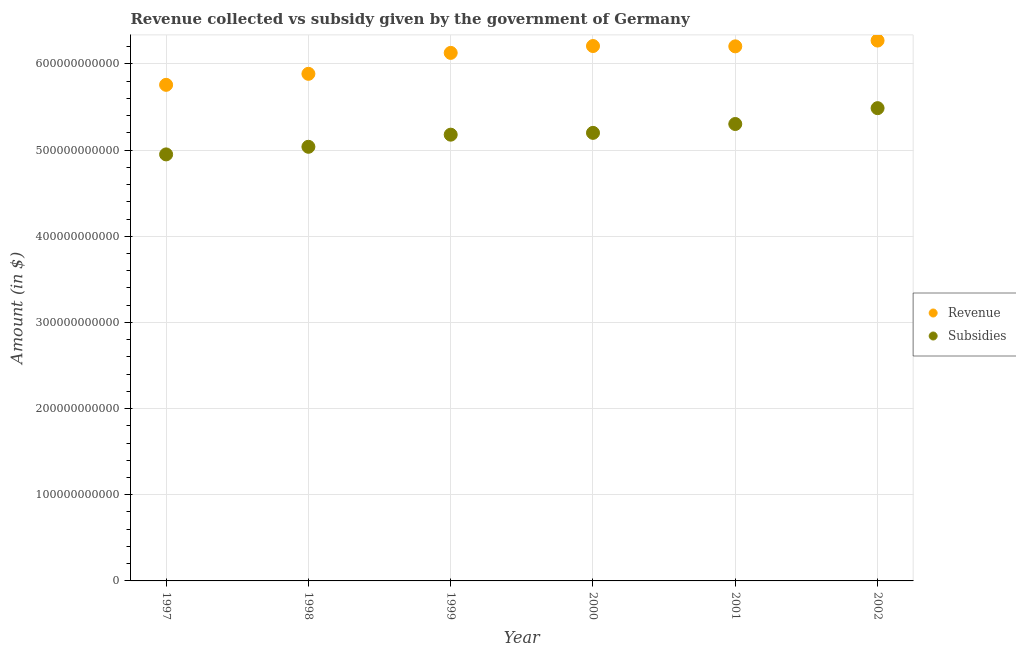Is the number of dotlines equal to the number of legend labels?
Keep it short and to the point. Yes. What is the amount of subsidies given in 1997?
Your answer should be compact. 4.95e+11. Across all years, what is the maximum amount of subsidies given?
Your answer should be compact. 5.49e+11. Across all years, what is the minimum amount of revenue collected?
Your response must be concise. 5.76e+11. In which year was the amount of subsidies given maximum?
Make the answer very short. 2002. What is the total amount of subsidies given in the graph?
Offer a terse response. 3.12e+12. What is the difference between the amount of revenue collected in 1998 and that in 2002?
Your response must be concise. -3.86e+1. What is the difference between the amount of revenue collected in 2001 and the amount of subsidies given in 2000?
Offer a terse response. 1.00e+11. What is the average amount of subsidies given per year?
Keep it short and to the point. 5.19e+11. In the year 2001, what is the difference between the amount of subsidies given and amount of revenue collected?
Ensure brevity in your answer.  -9.01e+1. What is the ratio of the amount of subsidies given in 2000 to that in 2001?
Offer a very short reply. 0.98. Is the difference between the amount of revenue collected in 1997 and 2001 greater than the difference between the amount of subsidies given in 1997 and 2001?
Give a very brief answer. No. What is the difference between the highest and the second highest amount of revenue collected?
Your answer should be very brief. 6.34e+09. What is the difference between the highest and the lowest amount of revenue collected?
Offer a terse response. 5.14e+1. In how many years, is the amount of subsidies given greater than the average amount of subsidies given taken over all years?
Your answer should be very brief. 3. Is the sum of the amount of revenue collected in 2000 and 2001 greater than the maximum amount of subsidies given across all years?
Ensure brevity in your answer.  Yes. Does the amount of subsidies given monotonically increase over the years?
Offer a very short reply. Yes. How many dotlines are there?
Your response must be concise. 2. What is the difference between two consecutive major ticks on the Y-axis?
Your answer should be very brief. 1.00e+11. Does the graph contain grids?
Offer a terse response. Yes. How many legend labels are there?
Keep it short and to the point. 2. What is the title of the graph?
Keep it short and to the point. Revenue collected vs subsidy given by the government of Germany. Does "Forest land" appear as one of the legend labels in the graph?
Provide a succinct answer. No. What is the label or title of the Y-axis?
Your response must be concise. Amount (in $). What is the Amount (in $) in Revenue in 1997?
Offer a very short reply. 5.76e+11. What is the Amount (in $) in Subsidies in 1997?
Give a very brief answer. 4.95e+11. What is the Amount (in $) of Revenue in 1998?
Your response must be concise. 5.89e+11. What is the Amount (in $) in Subsidies in 1998?
Your answer should be compact. 5.04e+11. What is the Amount (in $) of Revenue in 1999?
Provide a succinct answer. 6.13e+11. What is the Amount (in $) of Subsidies in 1999?
Your answer should be compact. 5.18e+11. What is the Amount (in $) of Revenue in 2000?
Provide a succinct answer. 6.21e+11. What is the Amount (in $) in Subsidies in 2000?
Your answer should be very brief. 5.20e+11. What is the Amount (in $) of Revenue in 2001?
Your answer should be compact. 6.20e+11. What is the Amount (in $) in Subsidies in 2001?
Provide a short and direct response. 5.30e+11. What is the Amount (in $) of Revenue in 2002?
Offer a terse response. 6.27e+11. What is the Amount (in $) in Subsidies in 2002?
Your response must be concise. 5.49e+11. Across all years, what is the maximum Amount (in $) in Revenue?
Your response must be concise. 6.27e+11. Across all years, what is the maximum Amount (in $) in Subsidies?
Make the answer very short. 5.49e+11. Across all years, what is the minimum Amount (in $) in Revenue?
Provide a short and direct response. 5.76e+11. Across all years, what is the minimum Amount (in $) in Subsidies?
Offer a terse response. 4.95e+11. What is the total Amount (in $) in Revenue in the graph?
Your answer should be compact. 3.65e+12. What is the total Amount (in $) in Subsidies in the graph?
Give a very brief answer. 3.12e+12. What is the difference between the Amount (in $) of Revenue in 1997 and that in 1998?
Provide a short and direct response. -1.28e+1. What is the difference between the Amount (in $) in Subsidies in 1997 and that in 1998?
Keep it short and to the point. -8.83e+09. What is the difference between the Amount (in $) of Revenue in 1997 and that in 1999?
Offer a very short reply. -3.71e+1. What is the difference between the Amount (in $) of Subsidies in 1997 and that in 1999?
Your answer should be compact. -2.29e+1. What is the difference between the Amount (in $) of Revenue in 1997 and that in 2000?
Give a very brief answer. -4.50e+1. What is the difference between the Amount (in $) in Subsidies in 1997 and that in 2000?
Your answer should be compact. -2.50e+1. What is the difference between the Amount (in $) of Revenue in 1997 and that in 2001?
Provide a succinct answer. -4.47e+1. What is the difference between the Amount (in $) of Subsidies in 1997 and that in 2001?
Provide a succinct answer. -3.53e+1. What is the difference between the Amount (in $) in Revenue in 1997 and that in 2002?
Provide a succinct answer. -5.14e+1. What is the difference between the Amount (in $) of Subsidies in 1997 and that in 2002?
Your answer should be compact. -5.37e+1. What is the difference between the Amount (in $) of Revenue in 1998 and that in 1999?
Ensure brevity in your answer.  -2.43e+1. What is the difference between the Amount (in $) of Subsidies in 1998 and that in 1999?
Ensure brevity in your answer.  -1.41e+1. What is the difference between the Amount (in $) in Revenue in 1998 and that in 2000?
Give a very brief answer. -3.23e+1. What is the difference between the Amount (in $) of Subsidies in 1998 and that in 2000?
Offer a terse response. -1.62e+1. What is the difference between the Amount (in $) of Revenue in 1998 and that in 2001?
Provide a succinct answer. -3.19e+1. What is the difference between the Amount (in $) of Subsidies in 1998 and that in 2001?
Offer a very short reply. -2.64e+1. What is the difference between the Amount (in $) in Revenue in 1998 and that in 2002?
Your answer should be very brief. -3.86e+1. What is the difference between the Amount (in $) of Subsidies in 1998 and that in 2002?
Your answer should be compact. -4.48e+1. What is the difference between the Amount (in $) of Revenue in 1999 and that in 2000?
Ensure brevity in your answer.  -7.96e+09. What is the difference between the Amount (in $) of Subsidies in 1999 and that in 2000?
Your response must be concise. -2.09e+09. What is the difference between the Amount (in $) of Revenue in 1999 and that in 2001?
Ensure brevity in your answer.  -7.59e+09. What is the difference between the Amount (in $) of Subsidies in 1999 and that in 2001?
Your answer should be very brief. -1.24e+1. What is the difference between the Amount (in $) of Revenue in 1999 and that in 2002?
Offer a very short reply. -1.43e+1. What is the difference between the Amount (in $) in Subsidies in 1999 and that in 2002?
Make the answer very short. -3.08e+1. What is the difference between the Amount (in $) of Revenue in 2000 and that in 2001?
Ensure brevity in your answer.  3.70e+08. What is the difference between the Amount (in $) in Subsidies in 2000 and that in 2001?
Your response must be concise. -1.03e+1. What is the difference between the Amount (in $) of Revenue in 2000 and that in 2002?
Offer a terse response. -6.34e+09. What is the difference between the Amount (in $) in Subsidies in 2000 and that in 2002?
Provide a short and direct response. -2.87e+1. What is the difference between the Amount (in $) in Revenue in 2001 and that in 2002?
Your answer should be compact. -6.71e+09. What is the difference between the Amount (in $) of Subsidies in 2001 and that in 2002?
Offer a very short reply. -1.84e+1. What is the difference between the Amount (in $) in Revenue in 1997 and the Amount (in $) in Subsidies in 1998?
Provide a succinct answer. 7.19e+1. What is the difference between the Amount (in $) in Revenue in 1997 and the Amount (in $) in Subsidies in 1999?
Provide a succinct answer. 5.78e+1. What is the difference between the Amount (in $) in Revenue in 1997 and the Amount (in $) in Subsidies in 2000?
Offer a terse response. 5.57e+1. What is the difference between the Amount (in $) of Revenue in 1997 and the Amount (in $) of Subsidies in 2001?
Your answer should be very brief. 4.55e+1. What is the difference between the Amount (in $) in Revenue in 1997 and the Amount (in $) in Subsidies in 2002?
Offer a very short reply. 2.71e+1. What is the difference between the Amount (in $) of Revenue in 1998 and the Amount (in $) of Subsidies in 1999?
Make the answer very short. 7.06e+1. What is the difference between the Amount (in $) of Revenue in 1998 and the Amount (in $) of Subsidies in 2000?
Make the answer very short. 6.85e+1. What is the difference between the Amount (in $) of Revenue in 1998 and the Amount (in $) of Subsidies in 2001?
Provide a short and direct response. 5.82e+1. What is the difference between the Amount (in $) in Revenue in 1998 and the Amount (in $) in Subsidies in 2002?
Give a very brief answer. 3.98e+1. What is the difference between the Amount (in $) of Revenue in 1999 and the Amount (in $) of Subsidies in 2000?
Your answer should be compact. 9.28e+1. What is the difference between the Amount (in $) of Revenue in 1999 and the Amount (in $) of Subsidies in 2001?
Your answer should be compact. 8.25e+1. What is the difference between the Amount (in $) of Revenue in 1999 and the Amount (in $) of Subsidies in 2002?
Ensure brevity in your answer.  6.41e+1. What is the difference between the Amount (in $) in Revenue in 2000 and the Amount (in $) in Subsidies in 2001?
Provide a succinct answer. 9.05e+1. What is the difference between the Amount (in $) in Revenue in 2000 and the Amount (in $) in Subsidies in 2002?
Give a very brief answer. 7.21e+1. What is the difference between the Amount (in $) in Revenue in 2001 and the Amount (in $) in Subsidies in 2002?
Provide a short and direct response. 7.17e+1. What is the average Amount (in $) in Revenue per year?
Ensure brevity in your answer.  6.08e+11. What is the average Amount (in $) of Subsidies per year?
Your answer should be very brief. 5.19e+11. In the year 1997, what is the difference between the Amount (in $) in Revenue and Amount (in $) in Subsidies?
Keep it short and to the point. 8.07e+1. In the year 1998, what is the difference between the Amount (in $) in Revenue and Amount (in $) in Subsidies?
Offer a terse response. 8.47e+1. In the year 1999, what is the difference between the Amount (in $) in Revenue and Amount (in $) in Subsidies?
Make the answer very short. 9.49e+1. In the year 2000, what is the difference between the Amount (in $) in Revenue and Amount (in $) in Subsidies?
Provide a succinct answer. 1.01e+11. In the year 2001, what is the difference between the Amount (in $) in Revenue and Amount (in $) in Subsidies?
Your answer should be compact. 9.01e+1. In the year 2002, what is the difference between the Amount (in $) in Revenue and Amount (in $) in Subsidies?
Make the answer very short. 7.84e+1. What is the ratio of the Amount (in $) in Revenue in 1997 to that in 1998?
Offer a very short reply. 0.98. What is the ratio of the Amount (in $) in Subsidies in 1997 to that in 1998?
Your response must be concise. 0.98. What is the ratio of the Amount (in $) in Revenue in 1997 to that in 1999?
Offer a very short reply. 0.94. What is the ratio of the Amount (in $) of Subsidies in 1997 to that in 1999?
Make the answer very short. 0.96. What is the ratio of the Amount (in $) in Revenue in 1997 to that in 2000?
Ensure brevity in your answer.  0.93. What is the ratio of the Amount (in $) in Subsidies in 1997 to that in 2000?
Give a very brief answer. 0.95. What is the ratio of the Amount (in $) in Revenue in 1997 to that in 2001?
Give a very brief answer. 0.93. What is the ratio of the Amount (in $) of Subsidies in 1997 to that in 2001?
Your answer should be compact. 0.93. What is the ratio of the Amount (in $) of Revenue in 1997 to that in 2002?
Ensure brevity in your answer.  0.92. What is the ratio of the Amount (in $) in Subsidies in 1997 to that in 2002?
Offer a terse response. 0.9. What is the ratio of the Amount (in $) in Revenue in 1998 to that in 1999?
Ensure brevity in your answer.  0.96. What is the ratio of the Amount (in $) of Subsidies in 1998 to that in 1999?
Your answer should be compact. 0.97. What is the ratio of the Amount (in $) in Revenue in 1998 to that in 2000?
Ensure brevity in your answer.  0.95. What is the ratio of the Amount (in $) of Subsidies in 1998 to that in 2000?
Provide a succinct answer. 0.97. What is the ratio of the Amount (in $) in Revenue in 1998 to that in 2001?
Offer a terse response. 0.95. What is the ratio of the Amount (in $) in Subsidies in 1998 to that in 2001?
Your response must be concise. 0.95. What is the ratio of the Amount (in $) of Revenue in 1998 to that in 2002?
Your answer should be very brief. 0.94. What is the ratio of the Amount (in $) of Subsidies in 1998 to that in 2002?
Your answer should be very brief. 0.92. What is the ratio of the Amount (in $) in Revenue in 1999 to that in 2000?
Ensure brevity in your answer.  0.99. What is the ratio of the Amount (in $) in Subsidies in 1999 to that in 2001?
Offer a terse response. 0.98. What is the ratio of the Amount (in $) in Revenue in 1999 to that in 2002?
Your answer should be very brief. 0.98. What is the ratio of the Amount (in $) of Subsidies in 1999 to that in 2002?
Your answer should be compact. 0.94. What is the ratio of the Amount (in $) of Subsidies in 2000 to that in 2001?
Provide a succinct answer. 0.98. What is the ratio of the Amount (in $) in Subsidies in 2000 to that in 2002?
Provide a succinct answer. 0.95. What is the ratio of the Amount (in $) in Revenue in 2001 to that in 2002?
Keep it short and to the point. 0.99. What is the ratio of the Amount (in $) in Subsidies in 2001 to that in 2002?
Your answer should be compact. 0.97. What is the difference between the highest and the second highest Amount (in $) of Revenue?
Your answer should be very brief. 6.34e+09. What is the difference between the highest and the second highest Amount (in $) in Subsidies?
Provide a succinct answer. 1.84e+1. What is the difference between the highest and the lowest Amount (in $) in Revenue?
Keep it short and to the point. 5.14e+1. What is the difference between the highest and the lowest Amount (in $) in Subsidies?
Your response must be concise. 5.37e+1. 